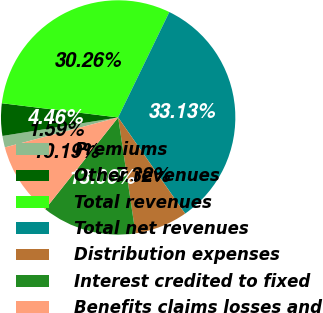Convert chart to OTSL. <chart><loc_0><loc_0><loc_500><loc_500><pie_chart><fcel>Premiums<fcel>Other revenues<fcel>Total revenues<fcel>Total net revenues<fcel>Distribution expenses<fcel>Interest credited to fixed<fcel>Benefits claims losses and<nl><fcel>1.59%<fcel>4.46%<fcel>30.26%<fcel>33.13%<fcel>7.32%<fcel>13.06%<fcel>10.19%<nl></chart> 